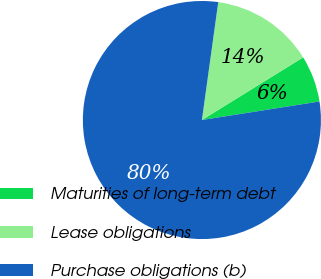Convert chart to OTSL. <chart><loc_0><loc_0><loc_500><loc_500><pie_chart><fcel>Maturities of long-term debt<fcel>Lease obligations<fcel>Purchase obligations (b)<nl><fcel>6.33%<fcel>13.99%<fcel>79.68%<nl></chart> 